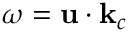<formula> <loc_0><loc_0><loc_500><loc_500>\omega = u \cdot k _ { c }</formula> 